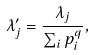Convert formula to latex. <formula><loc_0><loc_0><loc_500><loc_500>\lambda _ { j } ^ { \prime } = \frac { \lambda _ { j } } { \sum _ { i } p _ { i } ^ { q } } ,</formula> 